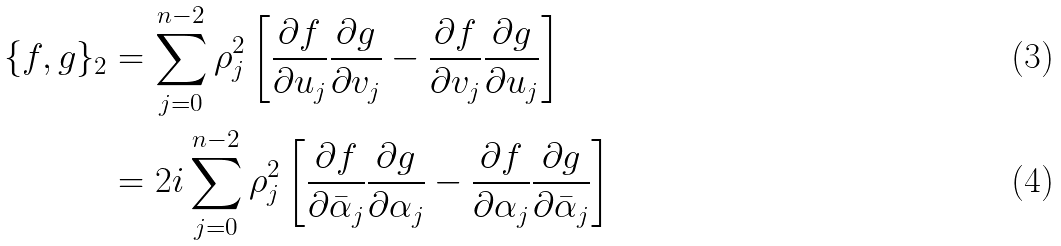Convert formula to latex. <formula><loc_0><loc_0><loc_500><loc_500>\{ f , g \} _ { 2 } & = \sum _ { j = 0 } ^ { n - 2 } \rho _ { j } ^ { 2 } \left [ \frac { \partial f } { \partial u _ { j } } \frac { \partial g } { \partial v _ { j } } - \frac { \partial f } { \partial v _ { j } } \frac { \partial g } { \partial u _ { j } } \right ] \\ & = 2 i \sum _ { j = 0 } ^ { n - 2 } \rho _ { j } ^ { 2 } \left [ \frac { \partial f } { \partial \bar { \alpha } _ { j } } \frac { \partial g } { \partial \alpha _ { j } } - \frac { \partial f } { \partial \alpha _ { j } } \frac { \partial g } { \partial \bar { \alpha } _ { j } } \right ]</formula> 